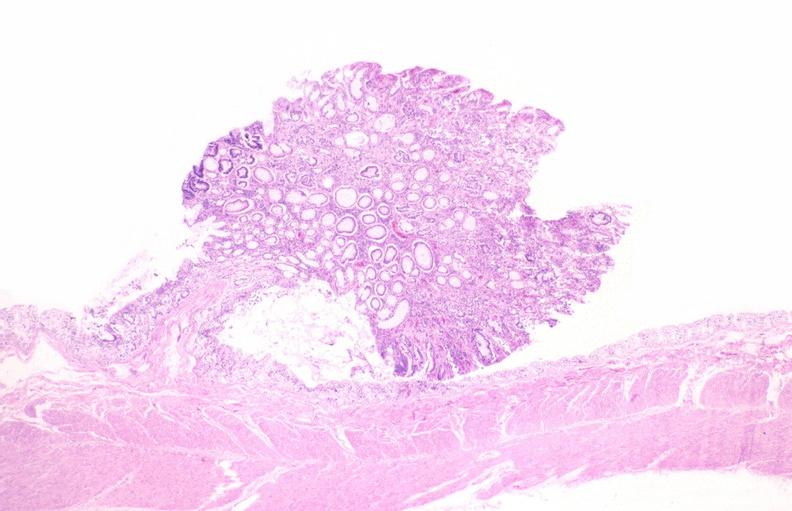does this image show colon, adenomatous polyp?
Answer the question using a single word or phrase. Yes 